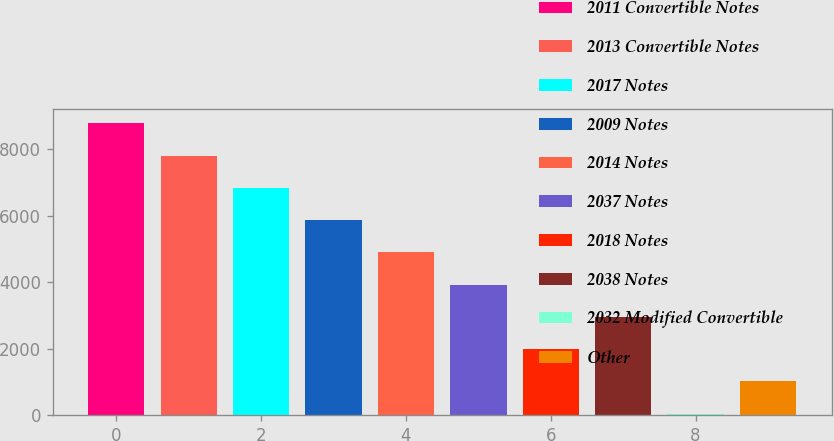Convert chart to OTSL. <chart><loc_0><loc_0><loc_500><loc_500><bar_chart><fcel>2011 Convertible Notes<fcel>2013 Convertible Notes<fcel>2017 Notes<fcel>2009 Notes<fcel>2014 Notes<fcel>2037 Notes<fcel>2018 Notes<fcel>2038 Notes<fcel>2032 Modified Convertible<fcel>Other<nl><fcel>8781.7<fcel>7812.4<fcel>6843.1<fcel>5873.8<fcel>4904.5<fcel>3935.2<fcel>1996.6<fcel>2965.9<fcel>58<fcel>1027.3<nl></chart> 